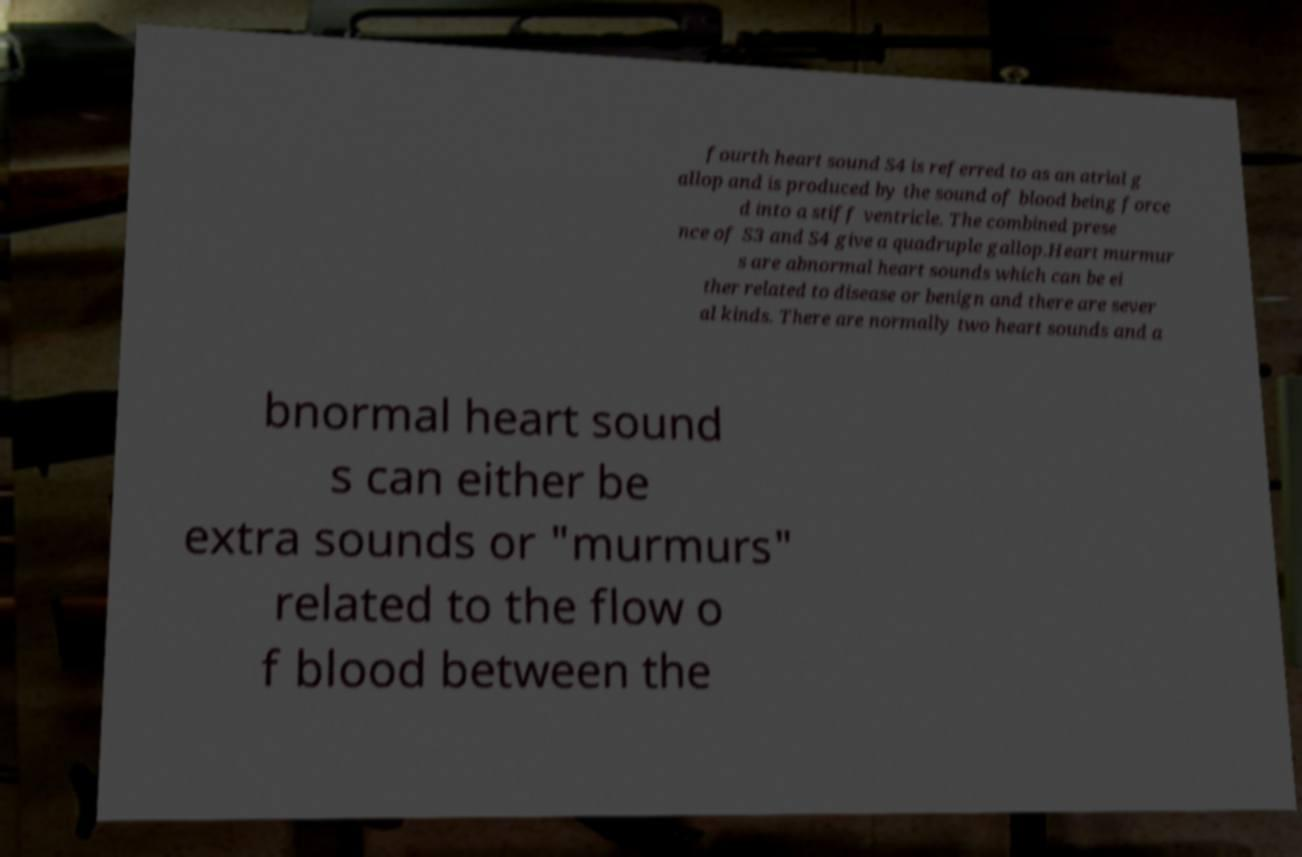Can you accurately transcribe the text from the provided image for me? fourth heart sound S4 is referred to as an atrial g allop and is produced by the sound of blood being force d into a stiff ventricle. The combined prese nce of S3 and S4 give a quadruple gallop.Heart murmur s are abnormal heart sounds which can be ei ther related to disease or benign and there are sever al kinds. There are normally two heart sounds and a bnormal heart sound s can either be extra sounds or "murmurs" related to the flow o f blood between the 